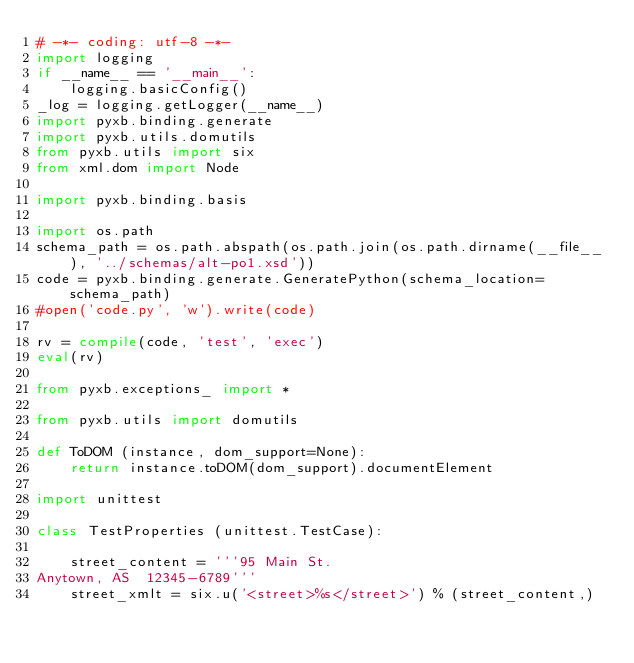Convert code to text. <code><loc_0><loc_0><loc_500><loc_500><_Python_># -*- coding: utf-8 -*-
import logging
if __name__ == '__main__':
    logging.basicConfig()
_log = logging.getLogger(__name__)
import pyxb.binding.generate
import pyxb.utils.domutils
from pyxb.utils import six
from xml.dom import Node

import pyxb.binding.basis

import os.path
schema_path = os.path.abspath(os.path.join(os.path.dirname(__file__), '../schemas/alt-po1.xsd'))
code = pyxb.binding.generate.GeneratePython(schema_location=schema_path)
#open('code.py', 'w').write(code)

rv = compile(code, 'test', 'exec')
eval(rv)

from pyxb.exceptions_ import *

from pyxb.utils import domutils

def ToDOM (instance, dom_support=None):
    return instance.toDOM(dom_support).documentElement

import unittest

class TestProperties (unittest.TestCase):

    street_content = '''95 Main St.
Anytown, AS  12345-6789'''
    street_xmlt = six.u('<street>%s</street>') % (street_content,)</code> 